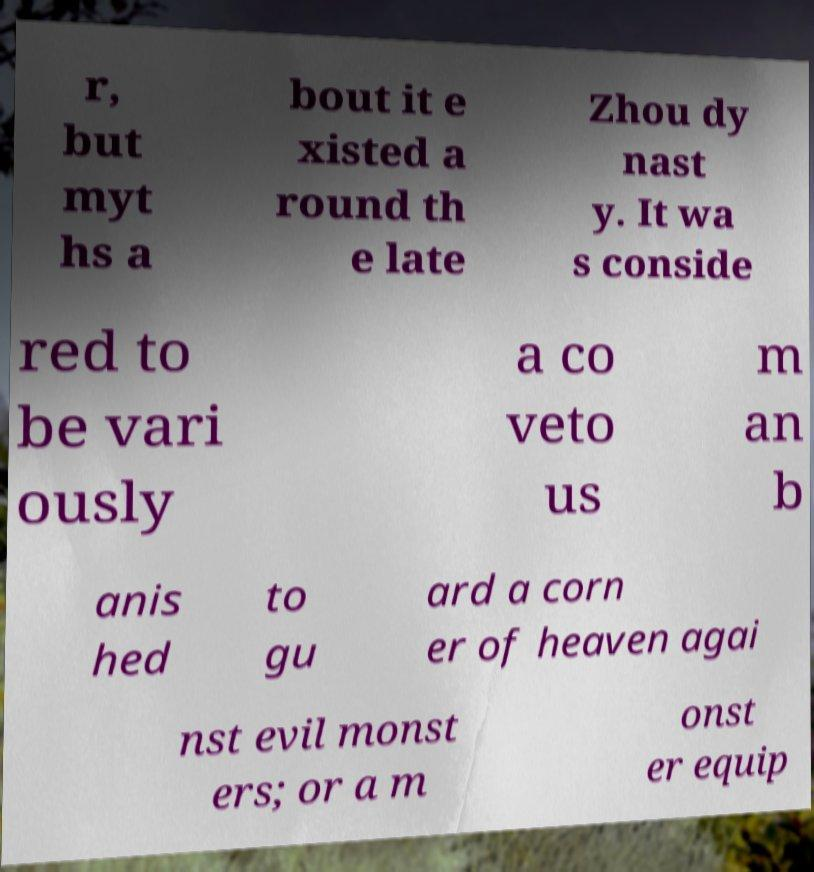Can you accurately transcribe the text from the provided image for me? r, but myt hs a bout it e xisted a round th e late Zhou dy nast y. It wa s conside red to be vari ously a co veto us m an b anis hed to gu ard a corn er of heaven agai nst evil monst ers; or a m onst er equip 